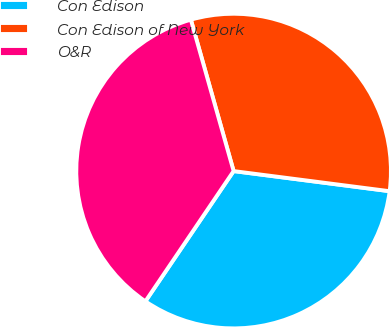Convert chart to OTSL. <chart><loc_0><loc_0><loc_500><loc_500><pie_chart><fcel>Con Edison<fcel>Con Edison of New York<fcel>O&R<nl><fcel>32.43%<fcel>31.42%<fcel>36.14%<nl></chart> 